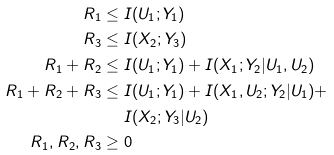Convert formula to latex. <formula><loc_0><loc_0><loc_500><loc_500>R _ { 1 } & \leq I ( U _ { 1 } ; Y _ { 1 } ) \\ R _ { 3 } & \leq I ( X _ { 2 } ; Y _ { 3 } ) \\ R _ { 1 } + R _ { 2 } & \leq I ( U _ { 1 } ; Y _ { 1 } ) + I ( X _ { 1 } ; Y _ { 2 } | U _ { 1 } , U _ { 2 } ) \\ R _ { 1 } + R _ { 2 } + R _ { 3 } & \leq I ( U _ { 1 } ; Y _ { 1 } ) + I ( X _ { 1 } , U _ { 2 } ; Y _ { 2 } | U _ { 1 } ) + \\ & \quad \ I ( X _ { 2 } ; Y _ { 3 } | U _ { 2 } ) \\ R _ { 1 } , R _ { 2 } , R _ { 3 } & \geq 0</formula> 